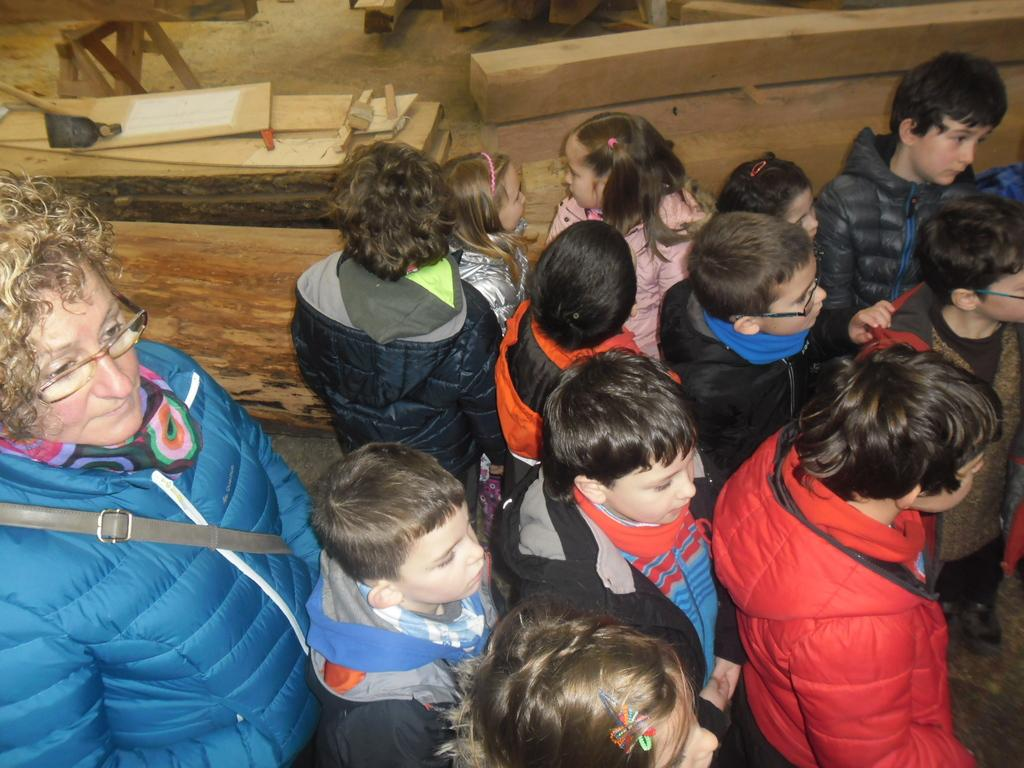Who or what can be seen in the image? There are people in the image. What can be seen in the background of the image? There are wooden logs in the background of the image. What type of dinosaurs can be seen interacting with the people in the image? There are no dinosaurs present in the image; it only features people and wooden logs in the background. 